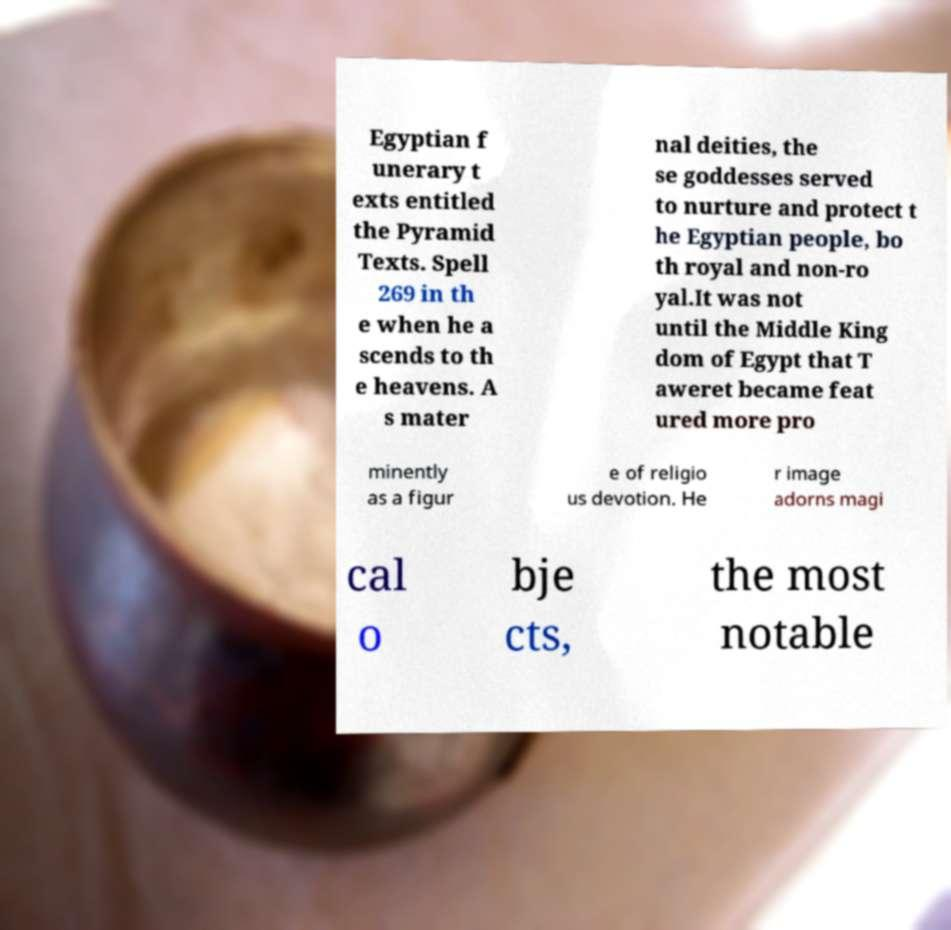Could you assist in decoding the text presented in this image and type it out clearly? Egyptian f unerary t exts entitled the Pyramid Texts. Spell 269 in th e when he a scends to th e heavens. A s mater nal deities, the se goddesses served to nurture and protect t he Egyptian people, bo th royal and non-ro yal.It was not until the Middle King dom of Egypt that T aweret became feat ured more pro minently as a figur e of religio us devotion. He r image adorns magi cal o bje cts, the most notable 